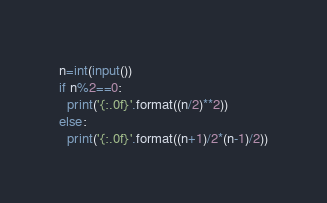Convert code to text. <code><loc_0><loc_0><loc_500><loc_500><_Python_>n=int(input())
if n%2==0:
  print('{:.0f}'.format((n/2)**2))
else:
  print('{:.0f}'.format((n+1)/2*(n-1)/2))</code> 